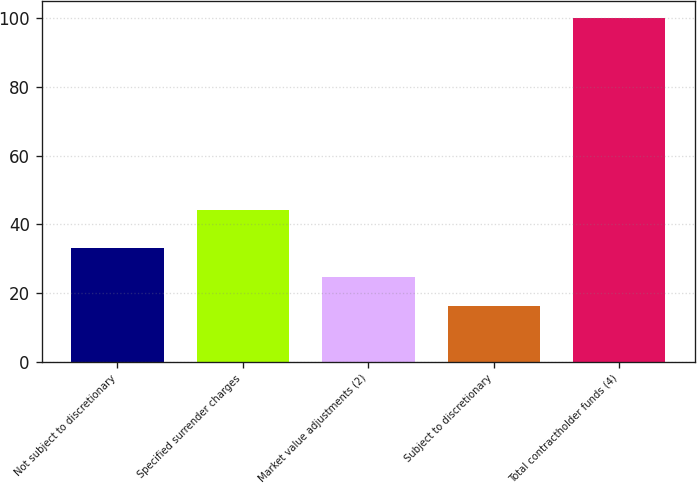<chart> <loc_0><loc_0><loc_500><loc_500><bar_chart><fcel>Not subject to discretionary<fcel>Specified surrender charges<fcel>Market value adjustments (2)<fcel>Subject to discretionary<fcel>Total contractholder funds (4)<nl><fcel>32.96<fcel>44.1<fcel>24.58<fcel>16.2<fcel>100<nl></chart> 